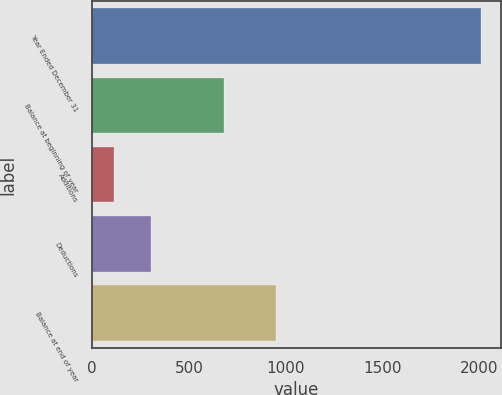Convert chart to OTSL. <chart><loc_0><loc_0><loc_500><loc_500><bar_chart><fcel>Year Ended December 31<fcel>Balance at beginning of year<fcel>Additions<fcel>Deductions<fcel>Balance at end of year<nl><fcel>2010<fcel>681<fcel>115<fcel>304.5<fcel>950<nl></chart> 